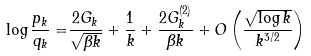<formula> <loc_0><loc_0><loc_500><loc_500>\log \frac { p _ { k } } { q _ { k } } = & \frac { 2 G _ { k } } { \sqrt { \beta k } } + \frac { 1 } { k } + \frac { 2 G _ { k } ^ { ( 2 ) } } { \beta k } + O \left ( \frac { \sqrt { \log k } } { k ^ { 3 / 2 } } \right )</formula> 